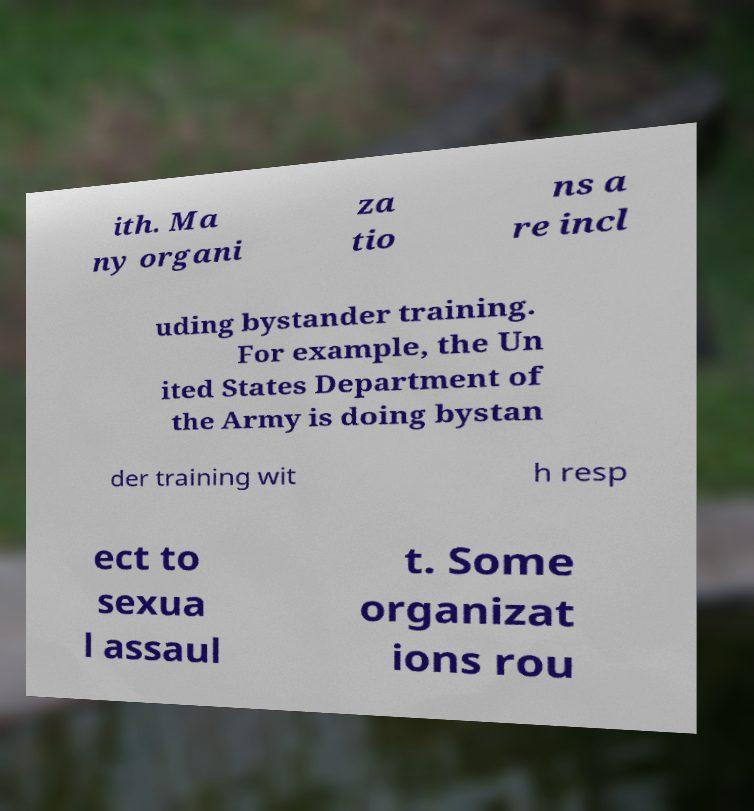Can you read and provide the text displayed in the image?This photo seems to have some interesting text. Can you extract and type it out for me? ith. Ma ny organi za tio ns a re incl uding bystander training. For example, the Un ited States Department of the Army is doing bystan der training wit h resp ect to sexua l assaul t. Some organizat ions rou 